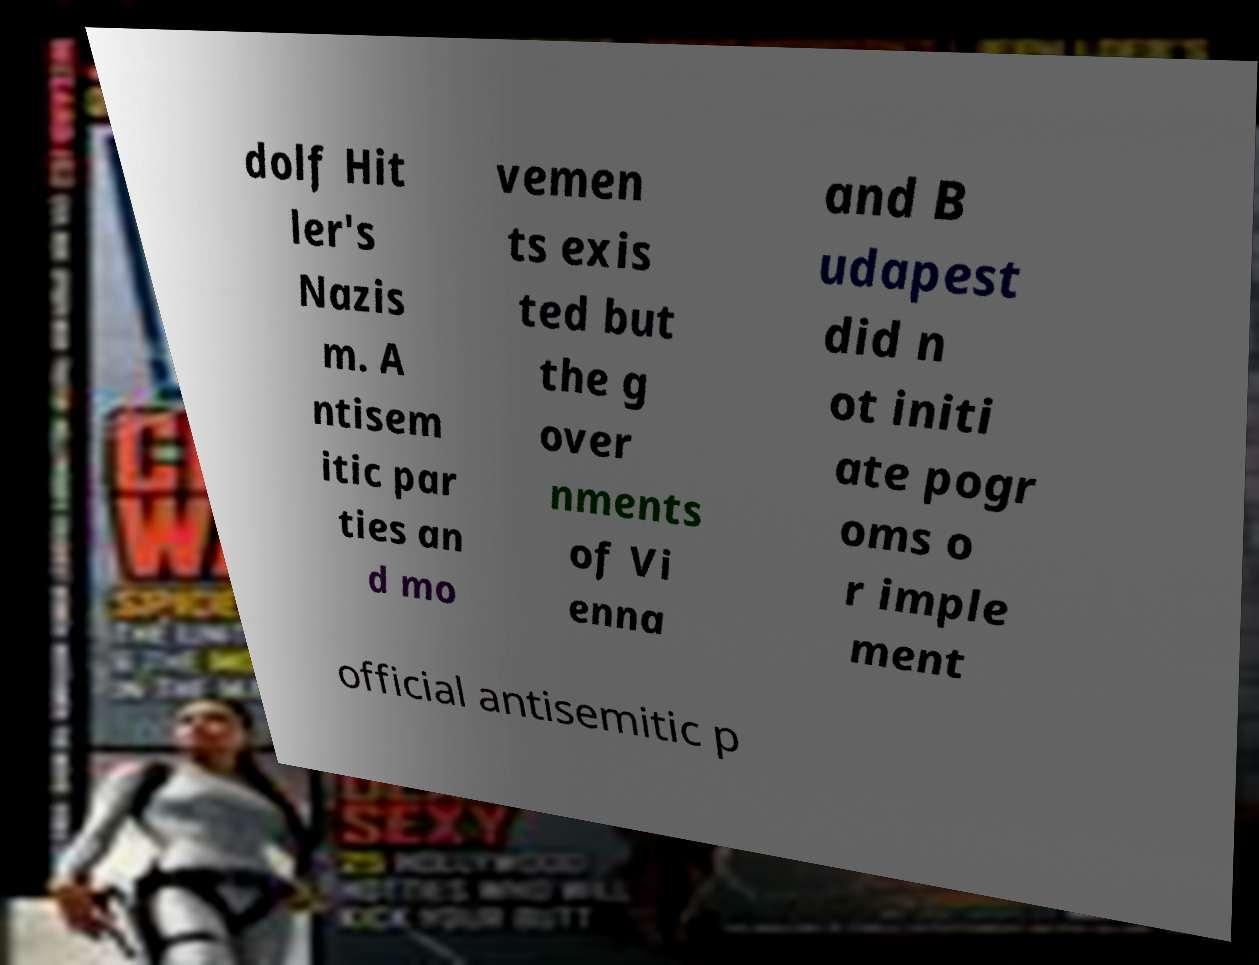What messages or text are displayed in this image? I need them in a readable, typed format. dolf Hit ler's Nazis m. A ntisem itic par ties an d mo vemen ts exis ted but the g over nments of Vi enna and B udapest did n ot initi ate pogr oms o r imple ment official antisemitic p 